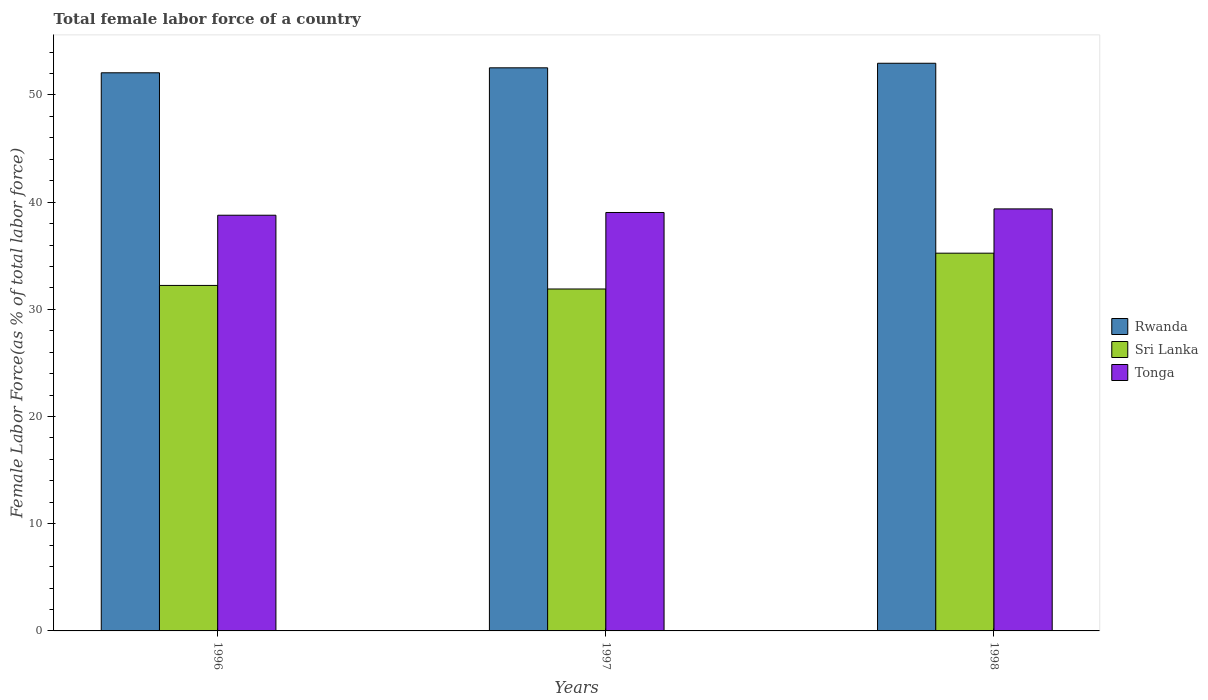How many different coloured bars are there?
Give a very brief answer. 3. Are the number of bars per tick equal to the number of legend labels?
Give a very brief answer. Yes. Are the number of bars on each tick of the X-axis equal?
Ensure brevity in your answer.  Yes. How many bars are there on the 1st tick from the right?
Keep it short and to the point. 3. In how many cases, is the number of bars for a given year not equal to the number of legend labels?
Make the answer very short. 0. What is the percentage of female labor force in Sri Lanka in 1997?
Offer a terse response. 31.9. Across all years, what is the maximum percentage of female labor force in Sri Lanka?
Provide a succinct answer. 35.24. Across all years, what is the minimum percentage of female labor force in Tonga?
Provide a succinct answer. 38.78. In which year was the percentage of female labor force in Rwanda maximum?
Offer a very short reply. 1998. What is the total percentage of female labor force in Rwanda in the graph?
Your answer should be very brief. 157.55. What is the difference between the percentage of female labor force in Tonga in 1996 and that in 1998?
Provide a succinct answer. -0.59. What is the difference between the percentage of female labor force in Tonga in 1997 and the percentage of female labor force in Sri Lanka in 1996?
Give a very brief answer. 6.8. What is the average percentage of female labor force in Sri Lanka per year?
Provide a short and direct response. 33.12. In the year 1998, what is the difference between the percentage of female labor force in Rwanda and percentage of female labor force in Tonga?
Keep it short and to the point. 13.59. In how many years, is the percentage of female labor force in Tonga greater than 50 %?
Your response must be concise. 0. What is the ratio of the percentage of female labor force in Rwanda in 1996 to that in 1998?
Keep it short and to the point. 0.98. Is the percentage of female labor force in Tonga in 1997 less than that in 1998?
Offer a terse response. Yes. What is the difference between the highest and the second highest percentage of female labor force in Sri Lanka?
Keep it short and to the point. 3.01. What is the difference between the highest and the lowest percentage of female labor force in Tonga?
Offer a very short reply. 0.59. What does the 3rd bar from the left in 1998 represents?
Ensure brevity in your answer.  Tonga. What does the 1st bar from the right in 1997 represents?
Provide a short and direct response. Tonga. How many years are there in the graph?
Make the answer very short. 3. Does the graph contain any zero values?
Your answer should be very brief. No. Does the graph contain grids?
Provide a succinct answer. No. Where does the legend appear in the graph?
Offer a terse response. Center right. How many legend labels are there?
Give a very brief answer. 3. What is the title of the graph?
Your answer should be compact. Total female labor force of a country. What is the label or title of the X-axis?
Your answer should be very brief. Years. What is the label or title of the Y-axis?
Give a very brief answer. Female Labor Force(as % of total labor force). What is the Female Labor Force(as % of total labor force) of Rwanda in 1996?
Your answer should be compact. 52.07. What is the Female Labor Force(as % of total labor force) in Sri Lanka in 1996?
Provide a succinct answer. 32.23. What is the Female Labor Force(as % of total labor force) of Tonga in 1996?
Your response must be concise. 38.78. What is the Female Labor Force(as % of total labor force) in Rwanda in 1997?
Offer a terse response. 52.53. What is the Female Labor Force(as % of total labor force) in Sri Lanka in 1997?
Provide a succinct answer. 31.9. What is the Female Labor Force(as % of total labor force) of Tonga in 1997?
Offer a very short reply. 39.03. What is the Female Labor Force(as % of total labor force) of Rwanda in 1998?
Make the answer very short. 52.96. What is the Female Labor Force(as % of total labor force) of Sri Lanka in 1998?
Ensure brevity in your answer.  35.24. What is the Female Labor Force(as % of total labor force) of Tonga in 1998?
Your answer should be very brief. 39.37. Across all years, what is the maximum Female Labor Force(as % of total labor force) in Rwanda?
Your answer should be compact. 52.96. Across all years, what is the maximum Female Labor Force(as % of total labor force) in Sri Lanka?
Your response must be concise. 35.24. Across all years, what is the maximum Female Labor Force(as % of total labor force) of Tonga?
Your response must be concise. 39.37. Across all years, what is the minimum Female Labor Force(as % of total labor force) of Rwanda?
Offer a very short reply. 52.07. Across all years, what is the minimum Female Labor Force(as % of total labor force) in Sri Lanka?
Provide a succinct answer. 31.9. Across all years, what is the minimum Female Labor Force(as % of total labor force) in Tonga?
Ensure brevity in your answer.  38.78. What is the total Female Labor Force(as % of total labor force) of Rwanda in the graph?
Make the answer very short. 157.55. What is the total Female Labor Force(as % of total labor force) in Sri Lanka in the graph?
Provide a succinct answer. 99.37. What is the total Female Labor Force(as % of total labor force) of Tonga in the graph?
Your response must be concise. 117.18. What is the difference between the Female Labor Force(as % of total labor force) of Rwanda in 1996 and that in 1997?
Ensure brevity in your answer.  -0.46. What is the difference between the Female Labor Force(as % of total labor force) in Sri Lanka in 1996 and that in 1997?
Offer a terse response. 0.33. What is the difference between the Female Labor Force(as % of total labor force) of Tonga in 1996 and that in 1997?
Your answer should be compact. -0.26. What is the difference between the Female Labor Force(as % of total labor force) in Rwanda in 1996 and that in 1998?
Your response must be concise. -0.89. What is the difference between the Female Labor Force(as % of total labor force) of Sri Lanka in 1996 and that in 1998?
Your response must be concise. -3.01. What is the difference between the Female Labor Force(as % of total labor force) in Tonga in 1996 and that in 1998?
Offer a terse response. -0.59. What is the difference between the Female Labor Force(as % of total labor force) in Rwanda in 1997 and that in 1998?
Offer a very short reply. -0.43. What is the difference between the Female Labor Force(as % of total labor force) of Sri Lanka in 1997 and that in 1998?
Provide a short and direct response. -3.34. What is the difference between the Female Labor Force(as % of total labor force) of Tonga in 1997 and that in 1998?
Give a very brief answer. -0.34. What is the difference between the Female Labor Force(as % of total labor force) of Rwanda in 1996 and the Female Labor Force(as % of total labor force) of Sri Lanka in 1997?
Make the answer very short. 20.17. What is the difference between the Female Labor Force(as % of total labor force) of Rwanda in 1996 and the Female Labor Force(as % of total labor force) of Tonga in 1997?
Offer a very short reply. 13.03. What is the difference between the Female Labor Force(as % of total labor force) in Sri Lanka in 1996 and the Female Labor Force(as % of total labor force) in Tonga in 1997?
Offer a terse response. -6.8. What is the difference between the Female Labor Force(as % of total labor force) in Rwanda in 1996 and the Female Labor Force(as % of total labor force) in Sri Lanka in 1998?
Make the answer very short. 16.83. What is the difference between the Female Labor Force(as % of total labor force) of Rwanda in 1996 and the Female Labor Force(as % of total labor force) of Tonga in 1998?
Provide a succinct answer. 12.7. What is the difference between the Female Labor Force(as % of total labor force) of Sri Lanka in 1996 and the Female Labor Force(as % of total labor force) of Tonga in 1998?
Provide a short and direct response. -7.14. What is the difference between the Female Labor Force(as % of total labor force) in Rwanda in 1997 and the Female Labor Force(as % of total labor force) in Sri Lanka in 1998?
Your answer should be very brief. 17.29. What is the difference between the Female Labor Force(as % of total labor force) of Rwanda in 1997 and the Female Labor Force(as % of total labor force) of Tonga in 1998?
Give a very brief answer. 13.16. What is the difference between the Female Labor Force(as % of total labor force) in Sri Lanka in 1997 and the Female Labor Force(as % of total labor force) in Tonga in 1998?
Your answer should be compact. -7.47. What is the average Female Labor Force(as % of total labor force) in Rwanda per year?
Ensure brevity in your answer.  52.52. What is the average Female Labor Force(as % of total labor force) of Sri Lanka per year?
Provide a succinct answer. 33.12. What is the average Female Labor Force(as % of total labor force) of Tonga per year?
Make the answer very short. 39.06. In the year 1996, what is the difference between the Female Labor Force(as % of total labor force) in Rwanda and Female Labor Force(as % of total labor force) in Sri Lanka?
Give a very brief answer. 19.84. In the year 1996, what is the difference between the Female Labor Force(as % of total labor force) of Rwanda and Female Labor Force(as % of total labor force) of Tonga?
Ensure brevity in your answer.  13.29. In the year 1996, what is the difference between the Female Labor Force(as % of total labor force) in Sri Lanka and Female Labor Force(as % of total labor force) in Tonga?
Give a very brief answer. -6.55. In the year 1997, what is the difference between the Female Labor Force(as % of total labor force) in Rwanda and Female Labor Force(as % of total labor force) in Sri Lanka?
Offer a very short reply. 20.63. In the year 1997, what is the difference between the Female Labor Force(as % of total labor force) of Rwanda and Female Labor Force(as % of total labor force) of Tonga?
Your answer should be compact. 13.5. In the year 1997, what is the difference between the Female Labor Force(as % of total labor force) of Sri Lanka and Female Labor Force(as % of total labor force) of Tonga?
Provide a succinct answer. -7.14. In the year 1998, what is the difference between the Female Labor Force(as % of total labor force) of Rwanda and Female Labor Force(as % of total labor force) of Sri Lanka?
Offer a very short reply. 17.72. In the year 1998, what is the difference between the Female Labor Force(as % of total labor force) in Rwanda and Female Labor Force(as % of total labor force) in Tonga?
Your answer should be compact. 13.59. In the year 1998, what is the difference between the Female Labor Force(as % of total labor force) of Sri Lanka and Female Labor Force(as % of total labor force) of Tonga?
Keep it short and to the point. -4.13. What is the ratio of the Female Labor Force(as % of total labor force) of Sri Lanka in 1996 to that in 1997?
Offer a terse response. 1.01. What is the ratio of the Female Labor Force(as % of total labor force) in Tonga in 1996 to that in 1997?
Offer a very short reply. 0.99. What is the ratio of the Female Labor Force(as % of total labor force) of Rwanda in 1996 to that in 1998?
Give a very brief answer. 0.98. What is the ratio of the Female Labor Force(as % of total labor force) of Sri Lanka in 1996 to that in 1998?
Keep it short and to the point. 0.91. What is the ratio of the Female Labor Force(as % of total labor force) of Rwanda in 1997 to that in 1998?
Your answer should be compact. 0.99. What is the ratio of the Female Labor Force(as % of total labor force) of Sri Lanka in 1997 to that in 1998?
Your answer should be very brief. 0.91. What is the ratio of the Female Labor Force(as % of total labor force) of Tonga in 1997 to that in 1998?
Your response must be concise. 0.99. What is the difference between the highest and the second highest Female Labor Force(as % of total labor force) in Rwanda?
Your response must be concise. 0.43. What is the difference between the highest and the second highest Female Labor Force(as % of total labor force) in Sri Lanka?
Give a very brief answer. 3.01. What is the difference between the highest and the second highest Female Labor Force(as % of total labor force) of Tonga?
Your response must be concise. 0.34. What is the difference between the highest and the lowest Female Labor Force(as % of total labor force) of Rwanda?
Your answer should be very brief. 0.89. What is the difference between the highest and the lowest Female Labor Force(as % of total labor force) in Sri Lanka?
Offer a terse response. 3.34. What is the difference between the highest and the lowest Female Labor Force(as % of total labor force) of Tonga?
Make the answer very short. 0.59. 